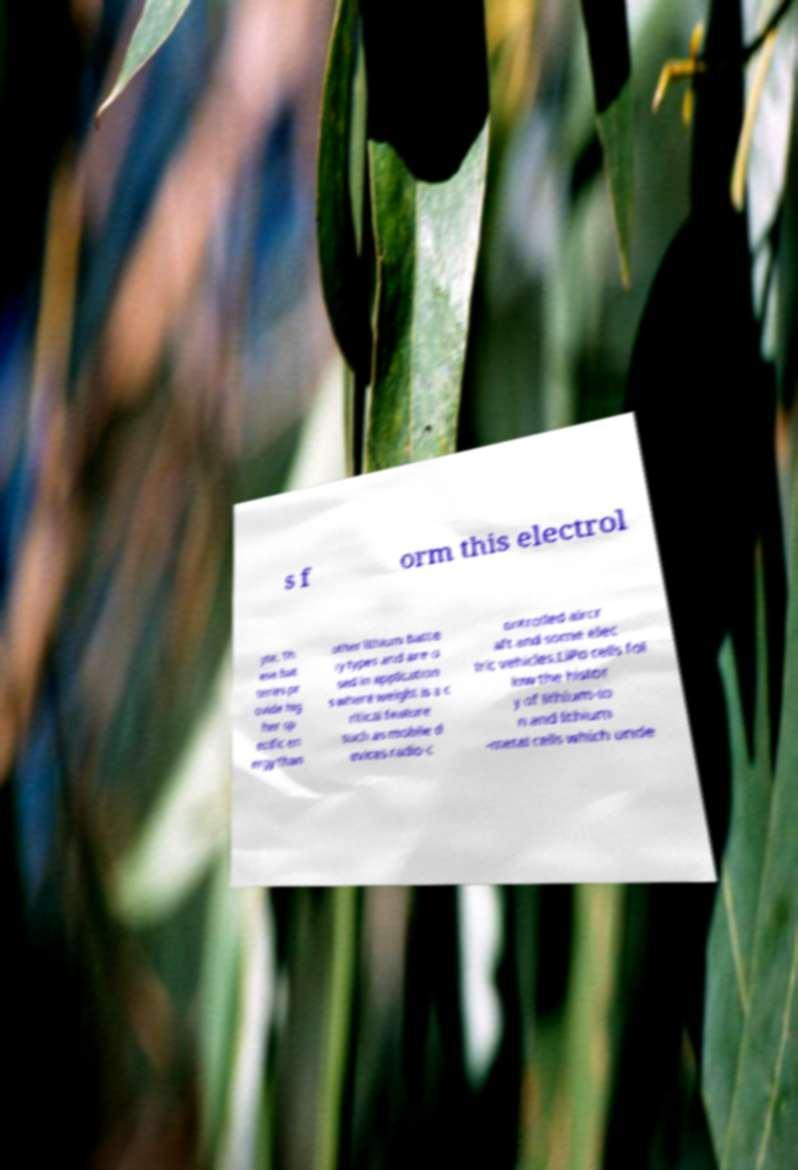Can you accurately transcribe the text from the provided image for me? s f orm this electrol yte. Th ese bat teries pr ovide hig her sp ecific en ergy than other lithium batte ry types and are u sed in application s where weight is a c ritical feature such as mobile d evices radio-c ontrolled aircr aft and some elec tric vehicles.LiPo cells fol low the histor y of lithium-io n and lithium -metal cells which unde 